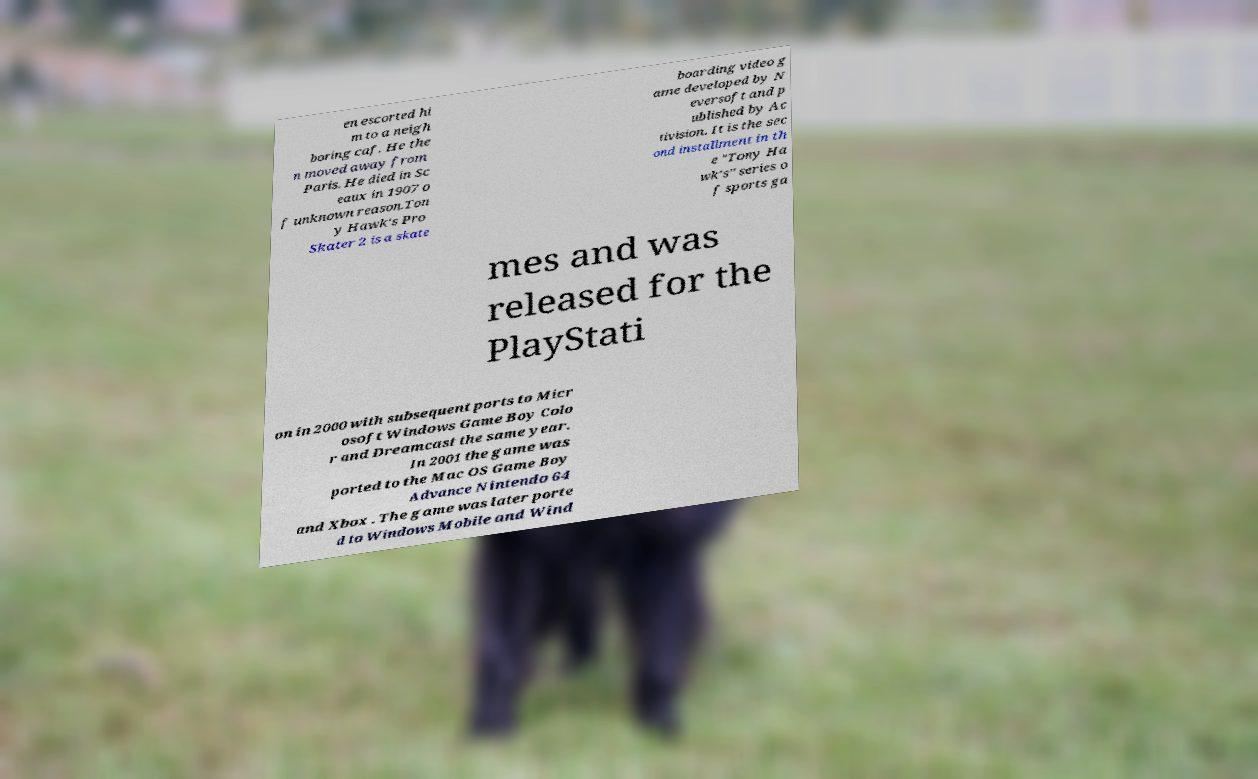Can you read and provide the text displayed in the image?This photo seems to have some interesting text. Can you extract and type it out for me? en escorted hi m to a neigh boring caf. He the n moved away from Paris. He died in Sc eaux in 1907 o f unknown reason.Ton y Hawk's Pro Skater 2 is a skate boarding video g ame developed by N eversoft and p ublished by Ac tivision. It is the sec ond installment in th e "Tony Ha wk's" series o f sports ga mes and was released for the PlayStati on in 2000 with subsequent ports to Micr osoft Windows Game Boy Colo r and Dreamcast the same year. In 2001 the game was ported to the Mac OS Game Boy Advance Nintendo 64 and Xbox . The game was later porte d to Windows Mobile and Wind 